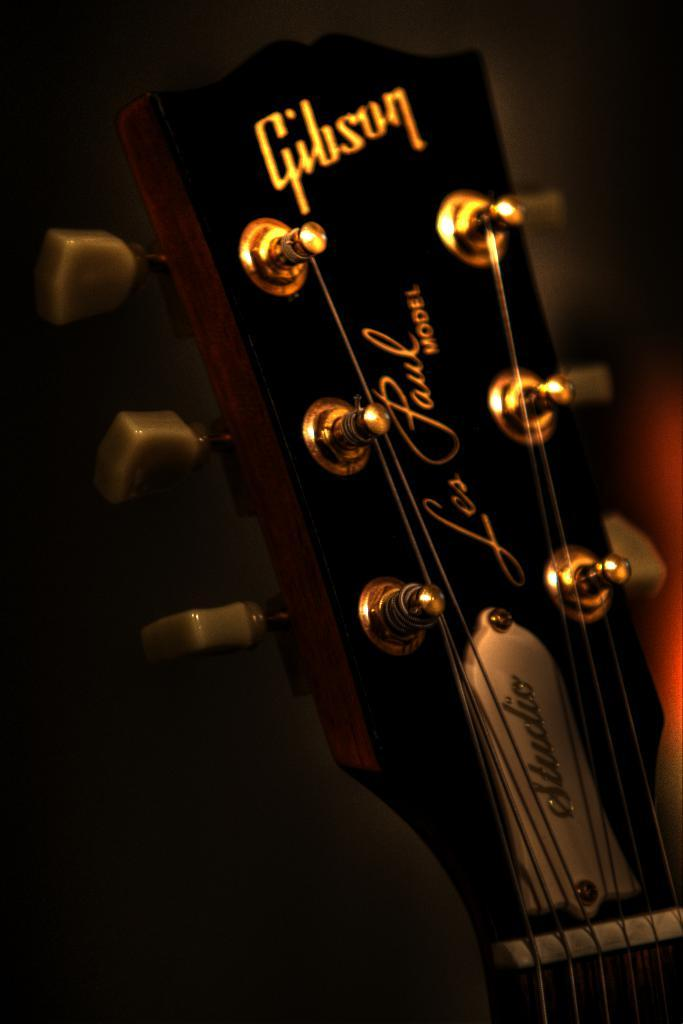What musical instrument is present in the image? There is a guitar in the image. What type of book is being used as a property to overcome fear in the image? There is no book or reference to fear present in the image; it only features a guitar. 